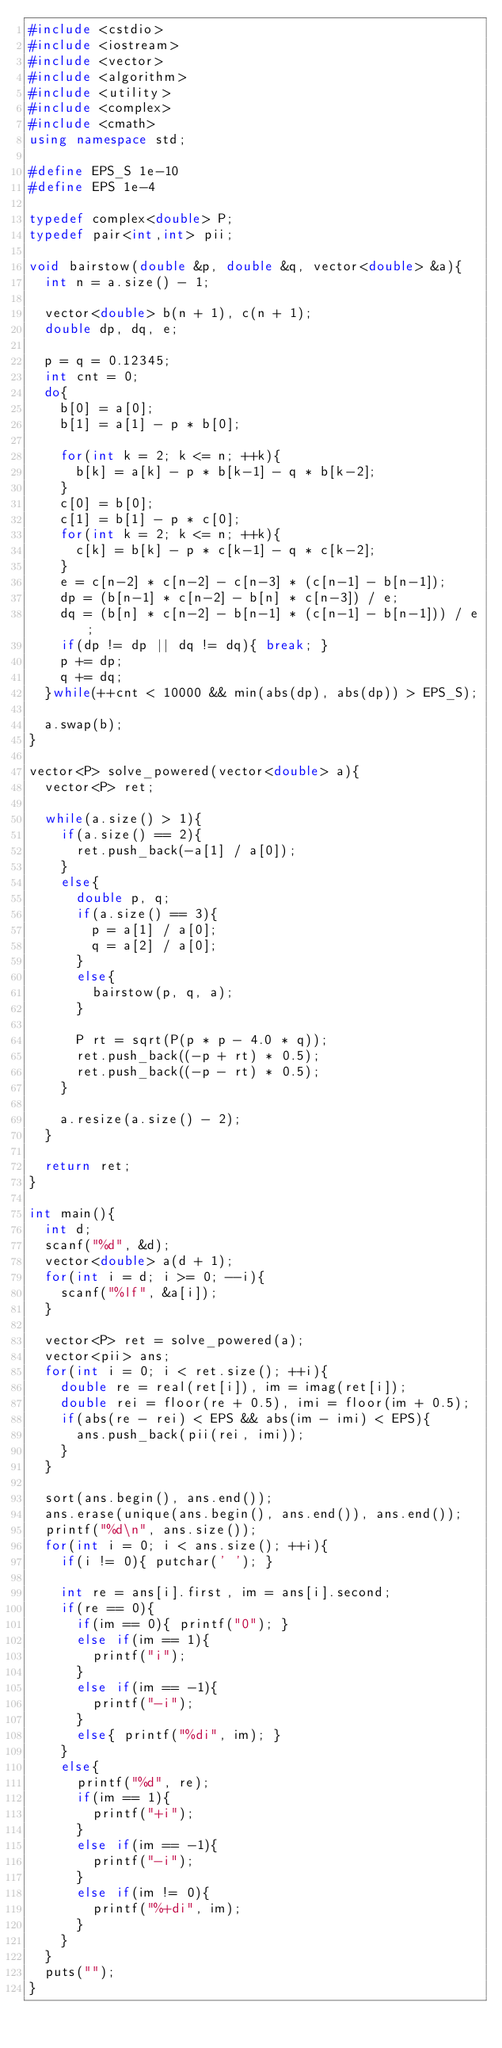<code> <loc_0><loc_0><loc_500><loc_500><_C++_>#include <cstdio>
#include <iostream>
#include <vector>
#include <algorithm>
#include <utility>
#include <complex>
#include <cmath>
using namespace std;

#define EPS_S 1e-10
#define EPS 1e-4

typedef complex<double> P;
typedef pair<int,int> pii;

void bairstow(double &p, double &q, vector<double> &a){
	int n = a.size() - 1;
	
	vector<double> b(n + 1), c(n + 1);
	double dp, dq, e;
	
	p = q = 0.12345;
	int cnt = 0;
	do{
		b[0] = a[0];
		b[1] = a[1] - p * b[0];
		
		for(int k = 2; k <= n; ++k){
			b[k] = a[k] - p * b[k-1] - q * b[k-2];
		}
		c[0] = b[0];
		c[1] = b[1] - p * c[0];
		for(int k = 2; k <= n; ++k){
			c[k] = b[k] - p * c[k-1] - q * c[k-2];
		}
		e = c[n-2] * c[n-2] - c[n-3] * (c[n-1] - b[n-1]);
		dp = (b[n-1] * c[n-2] - b[n] * c[n-3]) / e;
		dq = (b[n] * c[n-2] - b[n-1] * (c[n-1] - b[n-1])) / e;
		if(dp != dp || dq != dq){ break; }
		p += dp;
		q += dq;
	}while(++cnt < 10000 && min(abs(dp), abs(dp)) > EPS_S);
	
	a.swap(b);
}

vector<P> solve_powered(vector<double> a){
	vector<P> ret;

	while(a.size() > 1){
		if(a.size() == 2){
			ret.push_back(-a[1] / a[0]);
		}
		else{
			double p, q;
			if(a.size() == 3){
				p = a[1] / a[0];
				q = a[2] / a[0];
			}
			else{
				bairstow(p, q, a);
			}

			P rt = sqrt(P(p * p - 4.0 * q));
			ret.push_back((-p + rt) * 0.5);
			ret.push_back((-p - rt) * 0.5);
		}
		
		a.resize(a.size() - 2);
	}
	
	return ret;
}

int main(){
	int d;
	scanf("%d", &d);
	vector<double> a(d + 1);
	for(int i = d; i >= 0; --i){
		scanf("%lf", &a[i]);
	}

	vector<P> ret = solve_powered(a);
	vector<pii> ans;
	for(int i = 0; i < ret.size(); ++i){
		double re = real(ret[i]), im = imag(ret[i]);
		double rei = floor(re + 0.5), imi = floor(im + 0.5);
		if(abs(re - rei) < EPS && abs(im - imi) < EPS){
			ans.push_back(pii(rei, imi));
		}
	}
	
	sort(ans.begin(), ans.end());
	ans.erase(unique(ans.begin(), ans.end()), ans.end());
	printf("%d\n", ans.size());
	for(int i = 0; i < ans.size(); ++i){
		if(i != 0){ putchar(' '); }
		
		int re = ans[i].first, im = ans[i].second;
		if(re == 0){
			if(im == 0){ printf("0"); }
			else if(im == 1){
				printf("i");
			}
			else if(im == -1){
				printf("-i");
			}
			else{ printf("%di", im); }
		}
		else{
			printf("%d", re);
			if(im == 1){
				printf("+i");
			}
			else if(im == -1){
				printf("-i");
			}
			else if(im != 0){
				printf("%+di", im);
			}
		}
	}
	puts("");
}</code> 